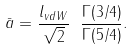Convert formula to latex. <formula><loc_0><loc_0><loc_500><loc_500>\bar { a } = \frac { l _ { v d W } } { \sqrt { 2 } } \ \frac { \Gamma ( 3 / 4 ) } { \Gamma ( 5 / 4 ) } .</formula> 